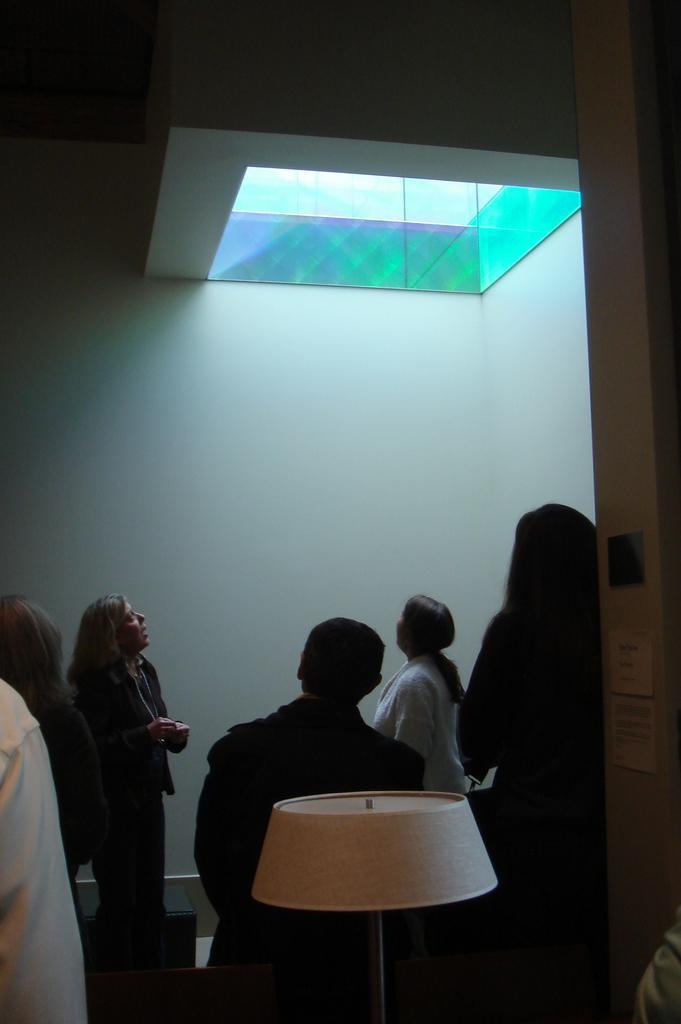How would you summarize this image in a sentence or two? In this image I can see number of persons standing, a lamp and a white colored wall. To the top of the image I can see the green and blue colored surface and light in it. I can see the dark colored background. 